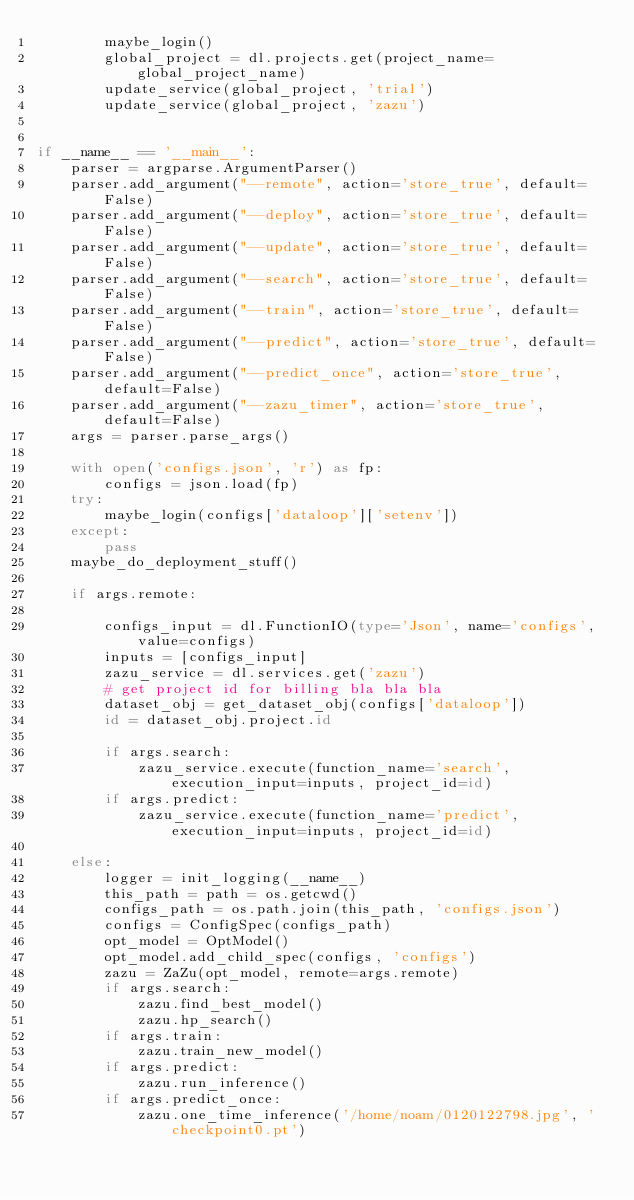Convert code to text. <code><loc_0><loc_0><loc_500><loc_500><_Python_>        maybe_login()
        global_project = dl.projects.get(project_name=global_project_name)
        update_service(global_project, 'trial')
        update_service(global_project, 'zazu')


if __name__ == '__main__':
    parser = argparse.ArgumentParser()
    parser.add_argument("--remote", action='store_true', default=False)
    parser.add_argument("--deploy", action='store_true', default=False)
    parser.add_argument("--update", action='store_true', default=False)
    parser.add_argument("--search", action='store_true', default=False)
    parser.add_argument("--train", action='store_true', default=False)
    parser.add_argument("--predict", action='store_true', default=False)
    parser.add_argument("--predict_once", action='store_true', default=False)
    parser.add_argument("--zazu_timer", action='store_true', default=False)
    args = parser.parse_args()

    with open('configs.json', 'r') as fp:
        configs = json.load(fp)
    try:
        maybe_login(configs['dataloop']['setenv'])
    except:
        pass
    maybe_do_deployment_stuff()

    if args.remote:

        configs_input = dl.FunctionIO(type='Json', name='configs', value=configs)
        inputs = [configs_input]
        zazu_service = dl.services.get('zazu')
        # get project id for billing bla bla bla
        dataset_obj = get_dataset_obj(configs['dataloop'])
        id = dataset_obj.project.id

        if args.search:
            zazu_service.execute(function_name='search', execution_input=inputs, project_id=id)
        if args.predict:
            zazu_service.execute(function_name='predict', execution_input=inputs, project_id=id)

    else:
        logger = init_logging(__name__)
        this_path = path = os.getcwd()
        configs_path = os.path.join(this_path, 'configs.json')
        configs = ConfigSpec(configs_path)
        opt_model = OptModel()
        opt_model.add_child_spec(configs, 'configs')
        zazu = ZaZu(opt_model, remote=args.remote)
        if args.search:
            zazu.find_best_model()
            zazu.hp_search()
        if args.train:
            zazu.train_new_model()
        if args.predict:
            zazu.run_inference()
        if args.predict_once:
            zazu.one_time_inference('/home/noam/0120122798.jpg', 'checkpoint0.pt')
</code> 